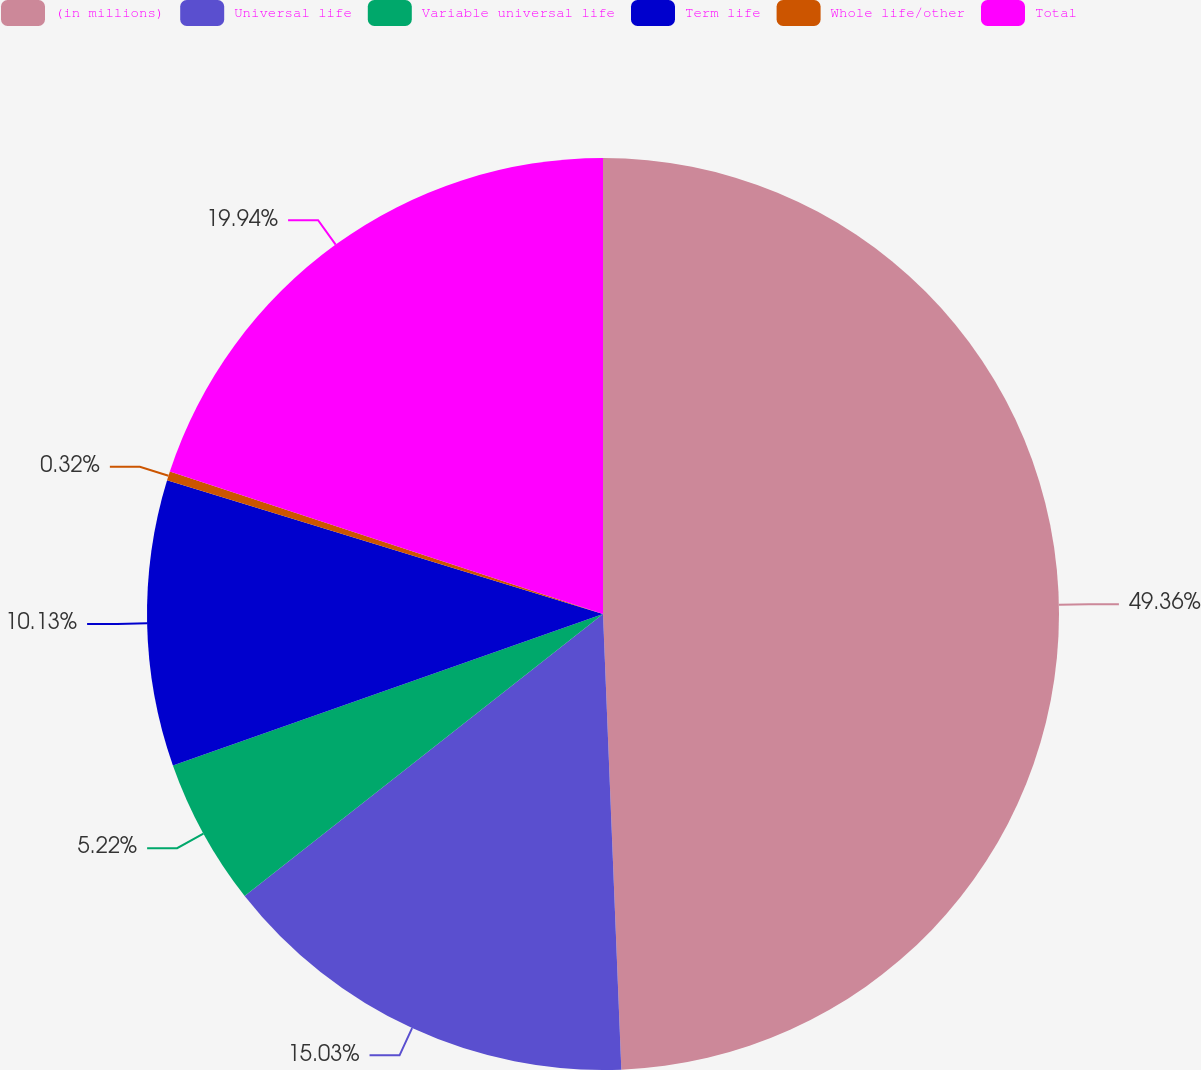<chart> <loc_0><loc_0><loc_500><loc_500><pie_chart><fcel>(in millions)<fcel>Universal life<fcel>Variable universal life<fcel>Term life<fcel>Whole life/other<fcel>Total<nl><fcel>49.36%<fcel>15.03%<fcel>5.22%<fcel>10.13%<fcel>0.32%<fcel>19.94%<nl></chart> 